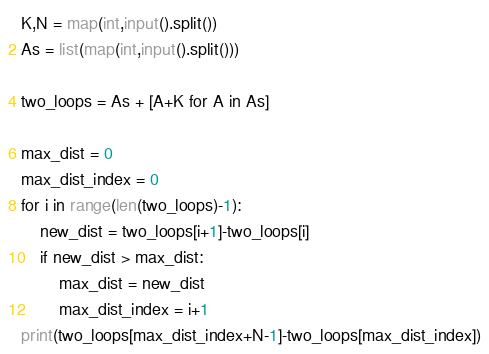Convert code to text. <code><loc_0><loc_0><loc_500><loc_500><_Python_>K,N = map(int,input().split())
As = list(map(int,input().split()))

two_loops = As + [A+K for A in As]

max_dist = 0
max_dist_index = 0
for i in range(len(two_loops)-1):
    new_dist = two_loops[i+1]-two_loops[i]
    if new_dist > max_dist:
        max_dist = new_dist
        max_dist_index = i+1
print(two_loops[max_dist_index+N-1]-two_loops[max_dist_index])</code> 